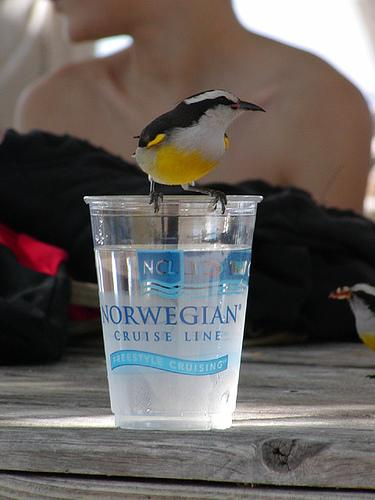What type of vehicle is this cup from? Please explain your reasoning. ship. The cup says "norwegian cruise line". 